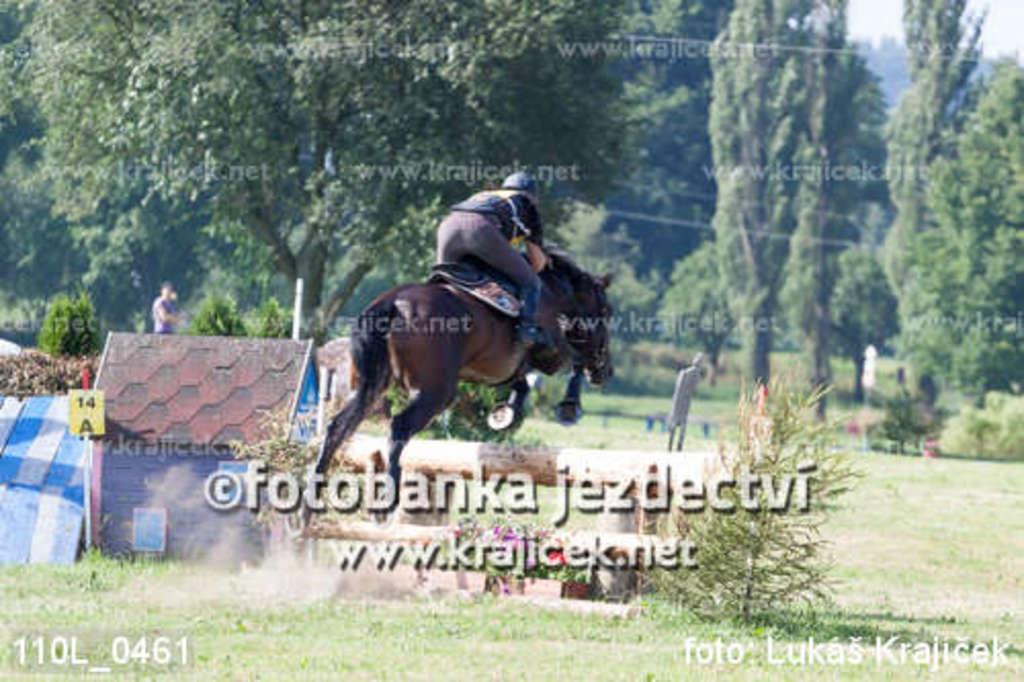Describe this image in one or two sentences. In the image there is a man sitting on the horse and it is jumping onto the wooden log. On the left side of the image there is a small room with roof. In the background there are many trees. At the bottom of the image there is grass and also there are small plants on the ground. And there are many watermarks in the image. 